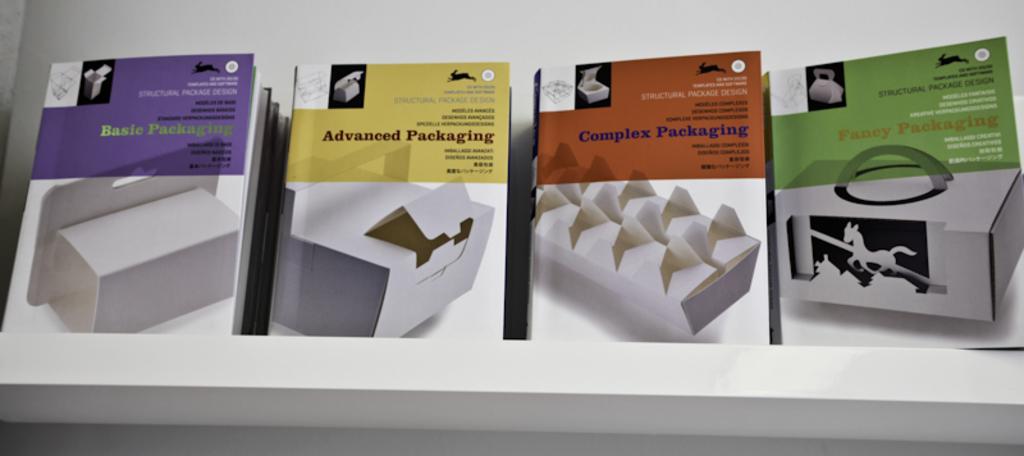What type of packaging is the yellow item?
Provide a short and direct response. Advanced. How many items are in the picture?
Offer a very short reply. 4. 